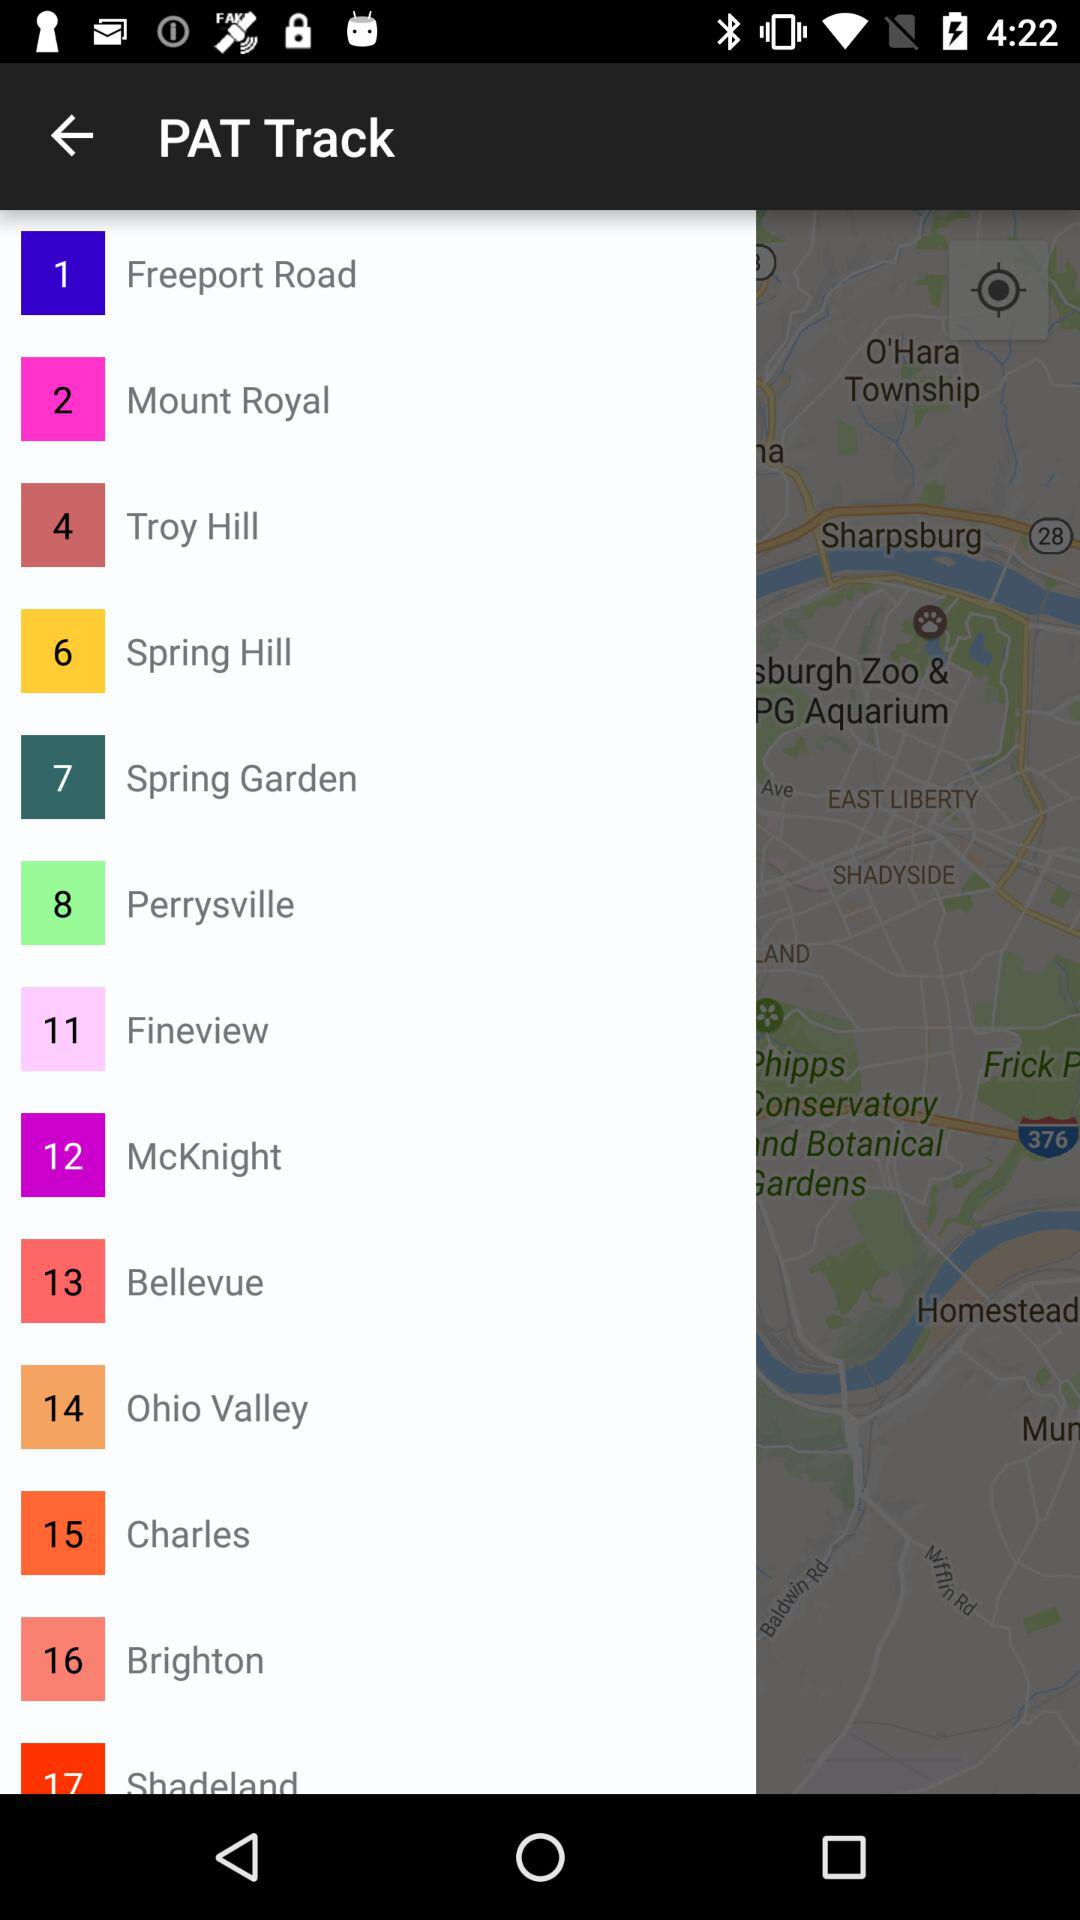How many stops are there on the PAT Track?
Answer the question using a single word or phrase. 17 